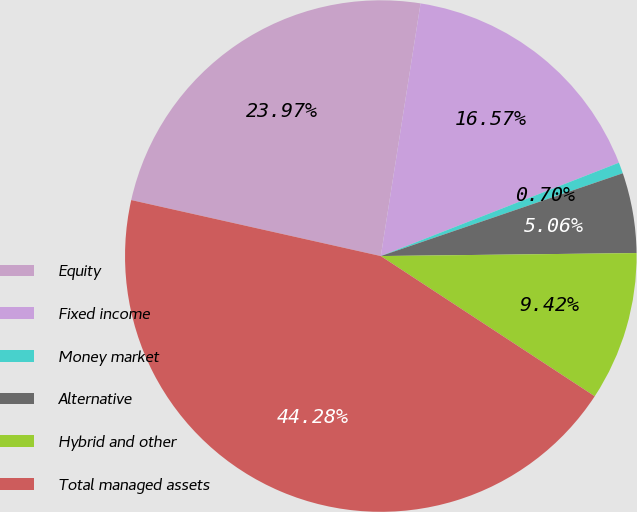<chart> <loc_0><loc_0><loc_500><loc_500><pie_chart><fcel>Equity<fcel>Fixed income<fcel>Money market<fcel>Alternative<fcel>Hybrid and other<fcel>Total managed assets<nl><fcel>23.97%<fcel>16.57%<fcel>0.7%<fcel>5.06%<fcel>9.42%<fcel>44.28%<nl></chart> 